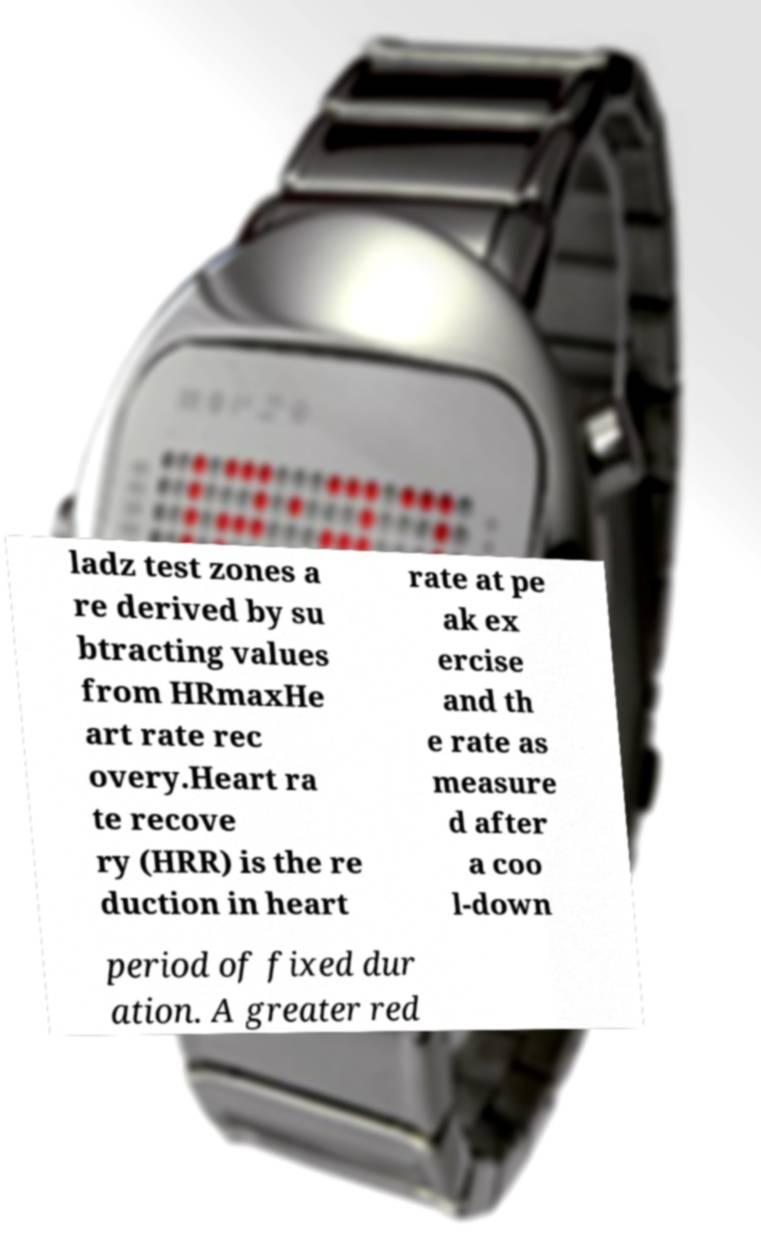What messages or text are displayed in this image? I need them in a readable, typed format. ladz test zones a re derived by su btracting values from HRmaxHe art rate rec overy.Heart ra te recove ry (HRR) is the re duction in heart rate at pe ak ex ercise and th e rate as measure d after a coo l-down period of fixed dur ation. A greater red 